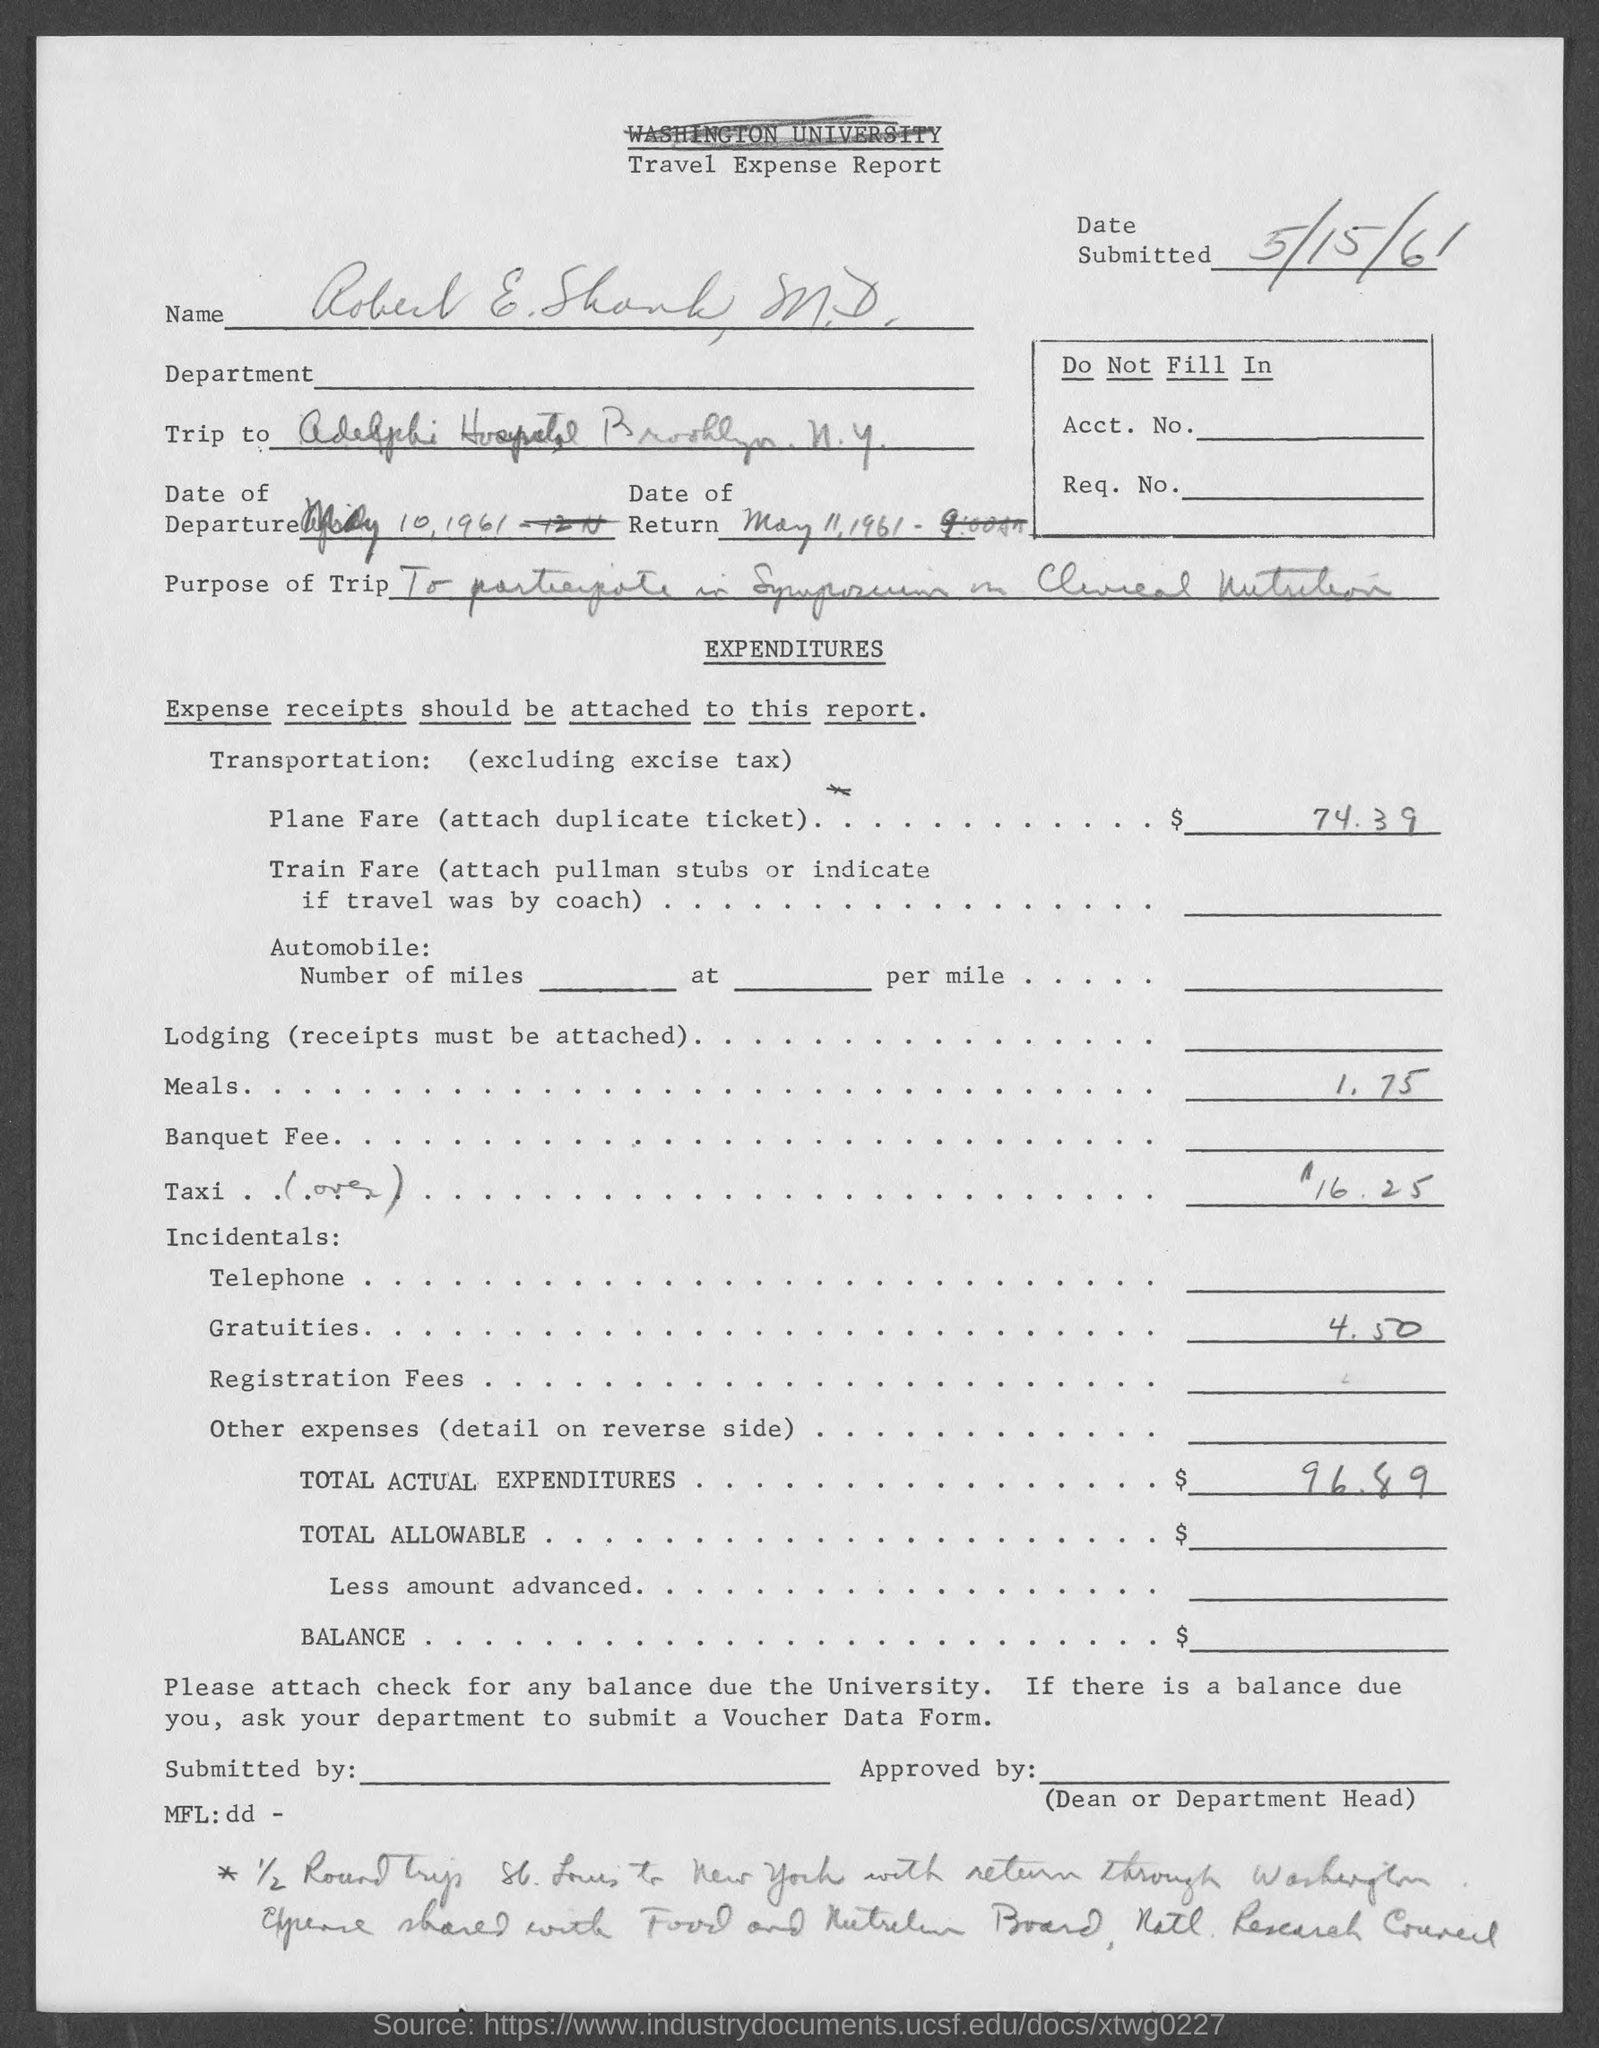What is the name of the report ?
Offer a very short reply. Travel Expense Report. 